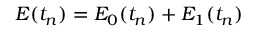<formula> <loc_0><loc_0><loc_500><loc_500>E ( t _ { n } ) = E _ { 0 } ( t _ { n } ) + E _ { 1 } ( t _ { n } )</formula> 